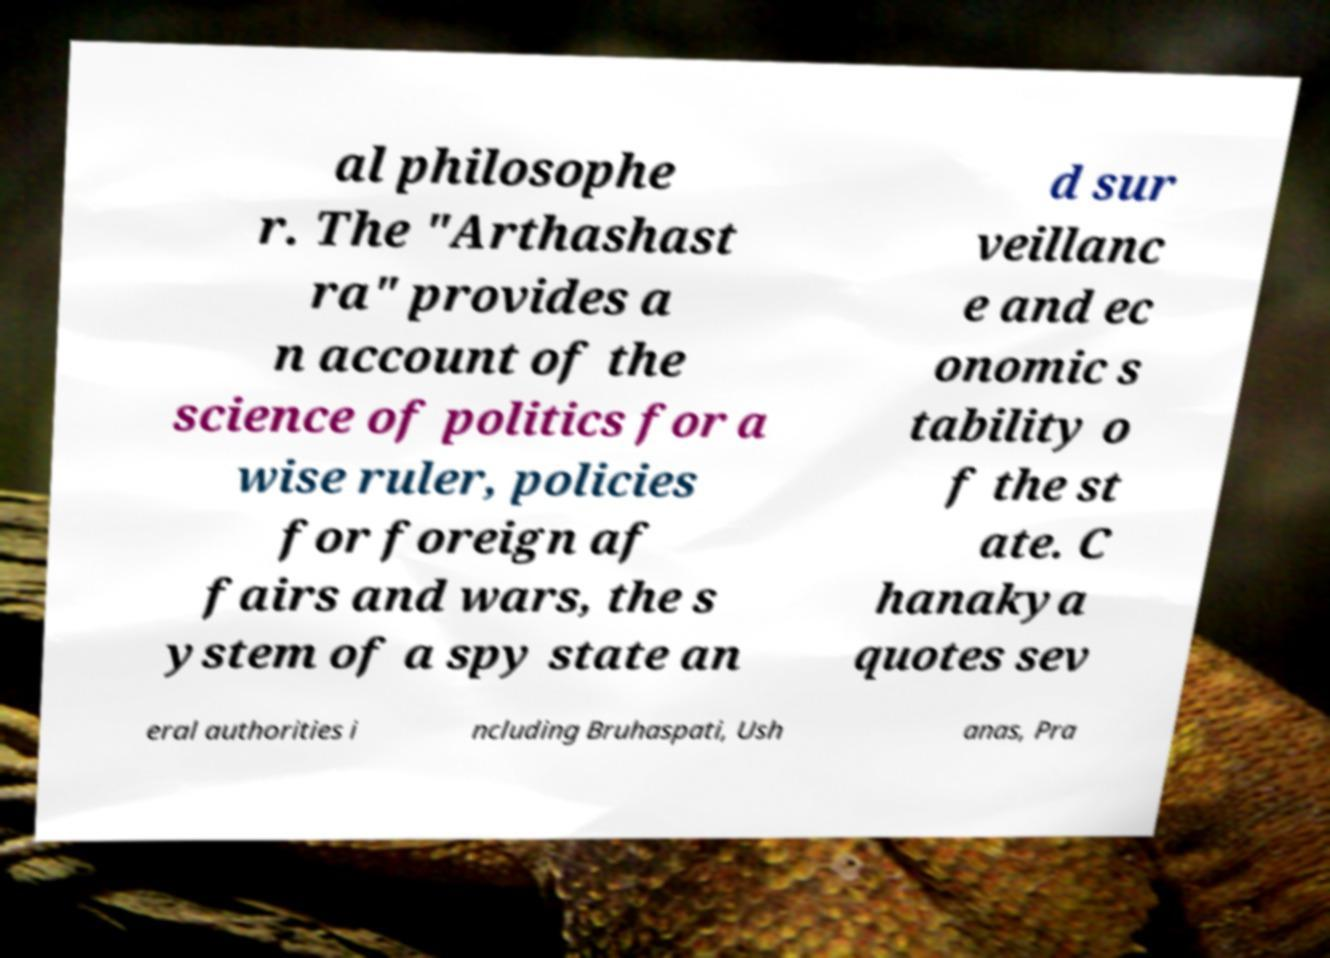What messages or text are displayed in this image? I need them in a readable, typed format. al philosophe r. The "Arthashast ra" provides a n account of the science of politics for a wise ruler, policies for foreign af fairs and wars, the s ystem of a spy state an d sur veillanc e and ec onomic s tability o f the st ate. C hanakya quotes sev eral authorities i ncluding Bruhaspati, Ush anas, Pra 